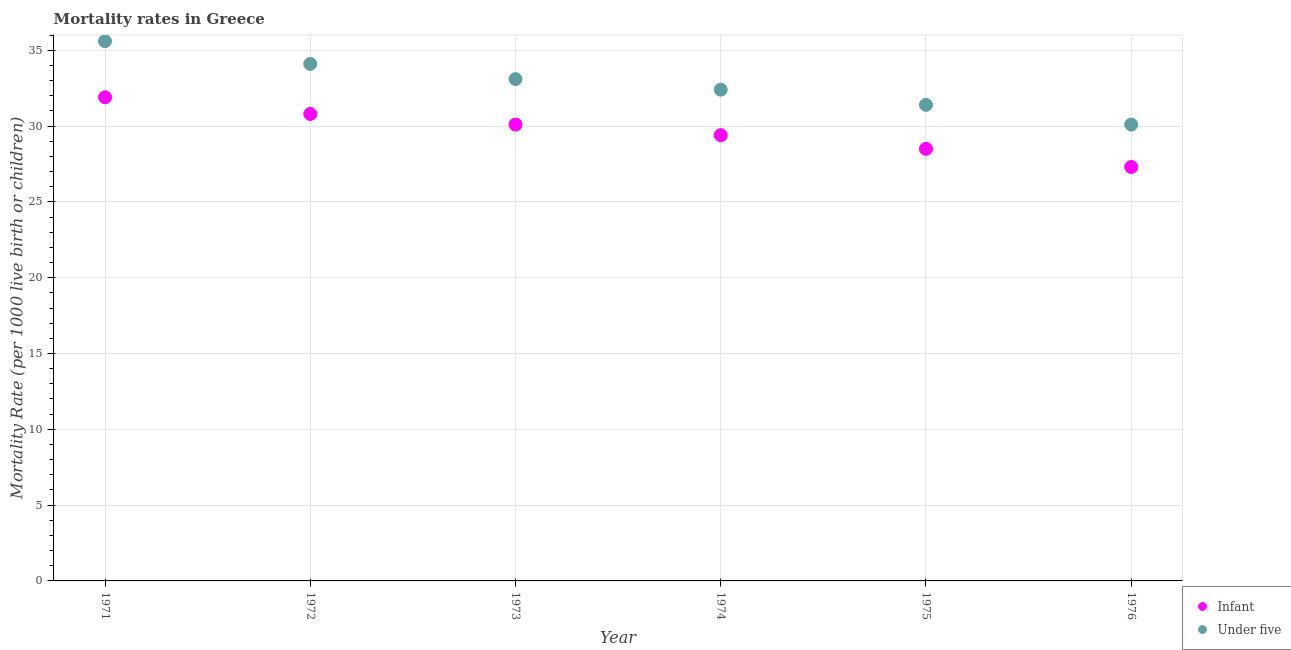Is the number of dotlines equal to the number of legend labels?
Give a very brief answer. Yes. What is the infant mortality rate in 1974?
Your response must be concise. 29.4. Across all years, what is the maximum under-5 mortality rate?
Provide a succinct answer. 35.6. Across all years, what is the minimum infant mortality rate?
Provide a succinct answer. 27.3. In which year was the infant mortality rate minimum?
Your answer should be very brief. 1976. What is the total under-5 mortality rate in the graph?
Your answer should be very brief. 196.7. What is the difference between the infant mortality rate in 1973 and that in 1976?
Provide a short and direct response. 2.8. What is the difference between the under-5 mortality rate in 1974 and the infant mortality rate in 1976?
Your response must be concise. 5.1. What is the average under-5 mortality rate per year?
Provide a succinct answer. 32.78. In the year 1971, what is the difference between the under-5 mortality rate and infant mortality rate?
Your answer should be very brief. 3.7. What is the ratio of the under-5 mortality rate in 1971 to that in 1972?
Offer a very short reply. 1.04. Is the under-5 mortality rate in 1972 less than that in 1976?
Ensure brevity in your answer.  No. What is the difference between the highest and the second highest under-5 mortality rate?
Ensure brevity in your answer.  1.5. What is the difference between the highest and the lowest infant mortality rate?
Keep it short and to the point. 4.6. Is the sum of the infant mortality rate in 1974 and 1975 greater than the maximum under-5 mortality rate across all years?
Your answer should be compact. Yes. Is the under-5 mortality rate strictly less than the infant mortality rate over the years?
Your answer should be compact. No. How many dotlines are there?
Keep it short and to the point. 2. How many years are there in the graph?
Make the answer very short. 6. What is the difference between two consecutive major ticks on the Y-axis?
Make the answer very short. 5. Does the graph contain any zero values?
Your answer should be compact. No. Does the graph contain grids?
Offer a terse response. Yes. Where does the legend appear in the graph?
Ensure brevity in your answer.  Bottom right. How many legend labels are there?
Provide a succinct answer. 2. How are the legend labels stacked?
Keep it short and to the point. Vertical. What is the title of the graph?
Provide a short and direct response. Mortality rates in Greece. Does "Revenue" appear as one of the legend labels in the graph?
Ensure brevity in your answer.  No. What is the label or title of the X-axis?
Provide a short and direct response. Year. What is the label or title of the Y-axis?
Keep it short and to the point. Mortality Rate (per 1000 live birth or children). What is the Mortality Rate (per 1000 live birth or children) of Infant in 1971?
Give a very brief answer. 31.9. What is the Mortality Rate (per 1000 live birth or children) of Under five in 1971?
Your response must be concise. 35.6. What is the Mortality Rate (per 1000 live birth or children) of Infant in 1972?
Give a very brief answer. 30.8. What is the Mortality Rate (per 1000 live birth or children) of Under five in 1972?
Your answer should be very brief. 34.1. What is the Mortality Rate (per 1000 live birth or children) of Infant in 1973?
Provide a short and direct response. 30.1. What is the Mortality Rate (per 1000 live birth or children) of Under five in 1973?
Ensure brevity in your answer.  33.1. What is the Mortality Rate (per 1000 live birth or children) in Infant in 1974?
Ensure brevity in your answer.  29.4. What is the Mortality Rate (per 1000 live birth or children) of Under five in 1974?
Offer a very short reply. 32.4. What is the Mortality Rate (per 1000 live birth or children) in Infant in 1975?
Give a very brief answer. 28.5. What is the Mortality Rate (per 1000 live birth or children) of Under five in 1975?
Offer a very short reply. 31.4. What is the Mortality Rate (per 1000 live birth or children) in Infant in 1976?
Your answer should be compact. 27.3. What is the Mortality Rate (per 1000 live birth or children) of Under five in 1976?
Your response must be concise. 30.1. Across all years, what is the maximum Mortality Rate (per 1000 live birth or children) of Infant?
Offer a very short reply. 31.9. Across all years, what is the maximum Mortality Rate (per 1000 live birth or children) of Under five?
Provide a short and direct response. 35.6. Across all years, what is the minimum Mortality Rate (per 1000 live birth or children) in Infant?
Keep it short and to the point. 27.3. Across all years, what is the minimum Mortality Rate (per 1000 live birth or children) of Under five?
Offer a terse response. 30.1. What is the total Mortality Rate (per 1000 live birth or children) of Infant in the graph?
Give a very brief answer. 178. What is the total Mortality Rate (per 1000 live birth or children) in Under five in the graph?
Your response must be concise. 196.7. What is the difference between the Mortality Rate (per 1000 live birth or children) in Infant in 1971 and that in 1972?
Make the answer very short. 1.1. What is the difference between the Mortality Rate (per 1000 live birth or children) of Infant in 1971 and that in 1973?
Your answer should be very brief. 1.8. What is the difference between the Mortality Rate (per 1000 live birth or children) in Under five in 1971 and that in 1973?
Ensure brevity in your answer.  2.5. What is the difference between the Mortality Rate (per 1000 live birth or children) of Infant in 1971 and that in 1974?
Ensure brevity in your answer.  2.5. What is the difference between the Mortality Rate (per 1000 live birth or children) of Under five in 1971 and that in 1974?
Offer a very short reply. 3.2. What is the difference between the Mortality Rate (per 1000 live birth or children) of Infant in 1971 and that in 1975?
Offer a very short reply. 3.4. What is the difference between the Mortality Rate (per 1000 live birth or children) in Under five in 1971 and that in 1975?
Offer a very short reply. 4.2. What is the difference between the Mortality Rate (per 1000 live birth or children) of Infant in 1971 and that in 1976?
Keep it short and to the point. 4.6. What is the difference between the Mortality Rate (per 1000 live birth or children) in Under five in 1971 and that in 1976?
Your answer should be very brief. 5.5. What is the difference between the Mortality Rate (per 1000 live birth or children) of Infant in 1972 and that in 1974?
Your answer should be very brief. 1.4. What is the difference between the Mortality Rate (per 1000 live birth or children) in Under five in 1972 and that in 1975?
Offer a terse response. 2.7. What is the difference between the Mortality Rate (per 1000 live birth or children) of Infant in 1972 and that in 1976?
Give a very brief answer. 3.5. What is the difference between the Mortality Rate (per 1000 live birth or children) of Infant in 1973 and that in 1974?
Offer a terse response. 0.7. What is the difference between the Mortality Rate (per 1000 live birth or children) of Infant in 1973 and that in 1975?
Your answer should be compact. 1.6. What is the difference between the Mortality Rate (per 1000 live birth or children) in Under five in 1973 and that in 1975?
Ensure brevity in your answer.  1.7. What is the difference between the Mortality Rate (per 1000 live birth or children) in Infant in 1973 and that in 1976?
Your response must be concise. 2.8. What is the difference between the Mortality Rate (per 1000 live birth or children) of Infant in 1974 and that in 1976?
Ensure brevity in your answer.  2.1. What is the difference between the Mortality Rate (per 1000 live birth or children) in Under five in 1974 and that in 1976?
Your answer should be very brief. 2.3. What is the difference between the Mortality Rate (per 1000 live birth or children) of Infant in 1975 and that in 1976?
Make the answer very short. 1.2. What is the difference between the Mortality Rate (per 1000 live birth or children) of Under five in 1975 and that in 1976?
Your answer should be very brief. 1.3. What is the difference between the Mortality Rate (per 1000 live birth or children) of Infant in 1971 and the Mortality Rate (per 1000 live birth or children) of Under five in 1972?
Provide a succinct answer. -2.2. What is the difference between the Mortality Rate (per 1000 live birth or children) of Infant in 1971 and the Mortality Rate (per 1000 live birth or children) of Under five in 1973?
Offer a very short reply. -1.2. What is the difference between the Mortality Rate (per 1000 live birth or children) in Infant in 1971 and the Mortality Rate (per 1000 live birth or children) in Under five in 1974?
Make the answer very short. -0.5. What is the difference between the Mortality Rate (per 1000 live birth or children) of Infant in 1971 and the Mortality Rate (per 1000 live birth or children) of Under five in 1976?
Give a very brief answer. 1.8. What is the difference between the Mortality Rate (per 1000 live birth or children) of Infant in 1972 and the Mortality Rate (per 1000 live birth or children) of Under five in 1975?
Make the answer very short. -0.6. What is the difference between the Mortality Rate (per 1000 live birth or children) in Infant in 1973 and the Mortality Rate (per 1000 live birth or children) in Under five in 1976?
Offer a terse response. 0. What is the difference between the Mortality Rate (per 1000 live birth or children) in Infant in 1975 and the Mortality Rate (per 1000 live birth or children) in Under five in 1976?
Keep it short and to the point. -1.6. What is the average Mortality Rate (per 1000 live birth or children) of Infant per year?
Your response must be concise. 29.67. What is the average Mortality Rate (per 1000 live birth or children) of Under five per year?
Provide a short and direct response. 32.78. In the year 1971, what is the difference between the Mortality Rate (per 1000 live birth or children) of Infant and Mortality Rate (per 1000 live birth or children) of Under five?
Give a very brief answer. -3.7. In the year 1973, what is the difference between the Mortality Rate (per 1000 live birth or children) in Infant and Mortality Rate (per 1000 live birth or children) in Under five?
Ensure brevity in your answer.  -3. In the year 1975, what is the difference between the Mortality Rate (per 1000 live birth or children) in Infant and Mortality Rate (per 1000 live birth or children) in Under five?
Make the answer very short. -2.9. In the year 1976, what is the difference between the Mortality Rate (per 1000 live birth or children) of Infant and Mortality Rate (per 1000 live birth or children) of Under five?
Offer a very short reply. -2.8. What is the ratio of the Mortality Rate (per 1000 live birth or children) of Infant in 1971 to that in 1972?
Give a very brief answer. 1.04. What is the ratio of the Mortality Rate (per 1000 live birth or children) in Under five in 1971 to that in 1972?
Provide a succinct answer. 1.04. What is the ratio of the Mortality Rate (per 1000 live birth or children) in Infant in 1971 to that in 1973?
Provide a short and direct response. 1.06. What is the ratio of the Mortality Rate (per 1000 live birth or children) in Under five in 1971 to that in 1973?
Keep it short and to the point. 1.08. What is the ratio of the Mortality Rate (per 1000 live birth or children) of Infant in 1971 to that in 1974?
Make the answer very short. 1.08. What is the ratio of the Mortality Rate (per 1000 live birth or children) of Under five in 1971 to that in 1974?
Keep it short and to the point. 1.1. What is the ratio of the Mortality Rate (per 1000 live birth or children) of Infant in 1971 to that in 1975?
Provide a succinct answer. 1.12. What is the ratio of the Mortality Rate (per 1000 live birth or children) in Under five in 1971 to that in 1975?
Ensure brevity in your answer.  1.13. What is the ratio of the Mortality Rate (per 1000 live birth or children) of Infant in 1971 to that in 1976?
Provide a succinct answer. 1.17. What is the ratio of the Mortality Rate (per 1000 live birth or children) in Under five in 1971 to that in 1976?
Offer a terse response. 1.18. What is the ratio of the Mortality Rate (per 1000 live birth or children) of Infant in 1972 to that in 1973?
Your answer should be compact. 1.02. What is the ratio of the Mortality Rate (per 1000 live birth or children) in Under five in 1972 to that in 1973?
Your response must be concise. 1.03. What is the ratio of the Mortality Rate (per 1000 live birth or children) in Infant in 1972 to that in 1974?
Give a very brief answer. 1.05. What is the ratio of the Mortality Rate (per 1000 live birth or children) in Under five in 1972 to that in 1974?
Offer a terse response. 1.05. What is the ratio of the Mortality Rate (per 1000 live birth or children) in Infant in 1972 to that in 1975?
Your answer should be compact. 1.08. What is the ratio of the Mortality Rate (per 1000 live birth or children) in Under five in 1972 to that in 1975?
Give a very brief answer. 1.09. What is the ratio of the Mortality Rate (per 1000 live birth or children) in Infant in 1972 to that in 1976?
Give a very brief answer. 1.13. What is the ratio of the Mortality Rate (per 1000 live birth or children) of Under five in 1972 to that in 1976?
Offer a very short reply. 1.13. What is the ratio of the Mortality Rate (per 1000 live birth or children) of Infant in 1973 to that in 1974?
Offer a very short reply. 1.02. What is the ratio of the Mortality Rate (per 1000 live birth or children) of Under five in 1973 to that in 1974?
Give a very brief answer. 1.02. What is the ratio of the Mortality Rate (per 1000 live birth or children) of Infant in 1973 to that in 1975?
Provide a succinct answer. 1.06. What is the ratio of the Mortality Rate (per 1000 live birth or children) in Under five in 1973 to that in 1975?
Your answer should be very brief. 1.05. What is the ratio of the Mortality Rate (per 1000 live birth or children) of Infant in 1973 to that in 1976?
Make the answer very short. 1.1. What is the ratio of the Mortality Rate (per 1000 live birth or children) in Under five in 1973 to that in 1976?
Make the answer very short. 1.1. What is the ratio of the Mortality Rate (per 1000 live birth or children) in Infant in 1974 to that in 1975?
Offer a terse response. 1.03. What is the ratio of the Mortality Rate (per 1000 live birth or children) of Under five in 1974 to that in 1975?
Provide a succinct answer. 1.03. What is the ratio of the Mortality Rate (per 1000 live birth or children) of Infant in 1974 to that in 1976?
Offer a very short reply. 1.08. What is the ratio of the Mortality Rate (per 1000 live birth or children) in Under five in 1974 to that in 1976?
Offer a very short reply. 1.08. What is the ratio of the Mortality Rate (per 1000 live birth or children) of Infant in 1975 to that in 1976?
Give a very brief answer. 1.04. What is the ratio of the Mortality Rate (per 1000 live birth or children) in Under five in 1975 to that in 1976?
Provide a succinct answer. 1.04. 